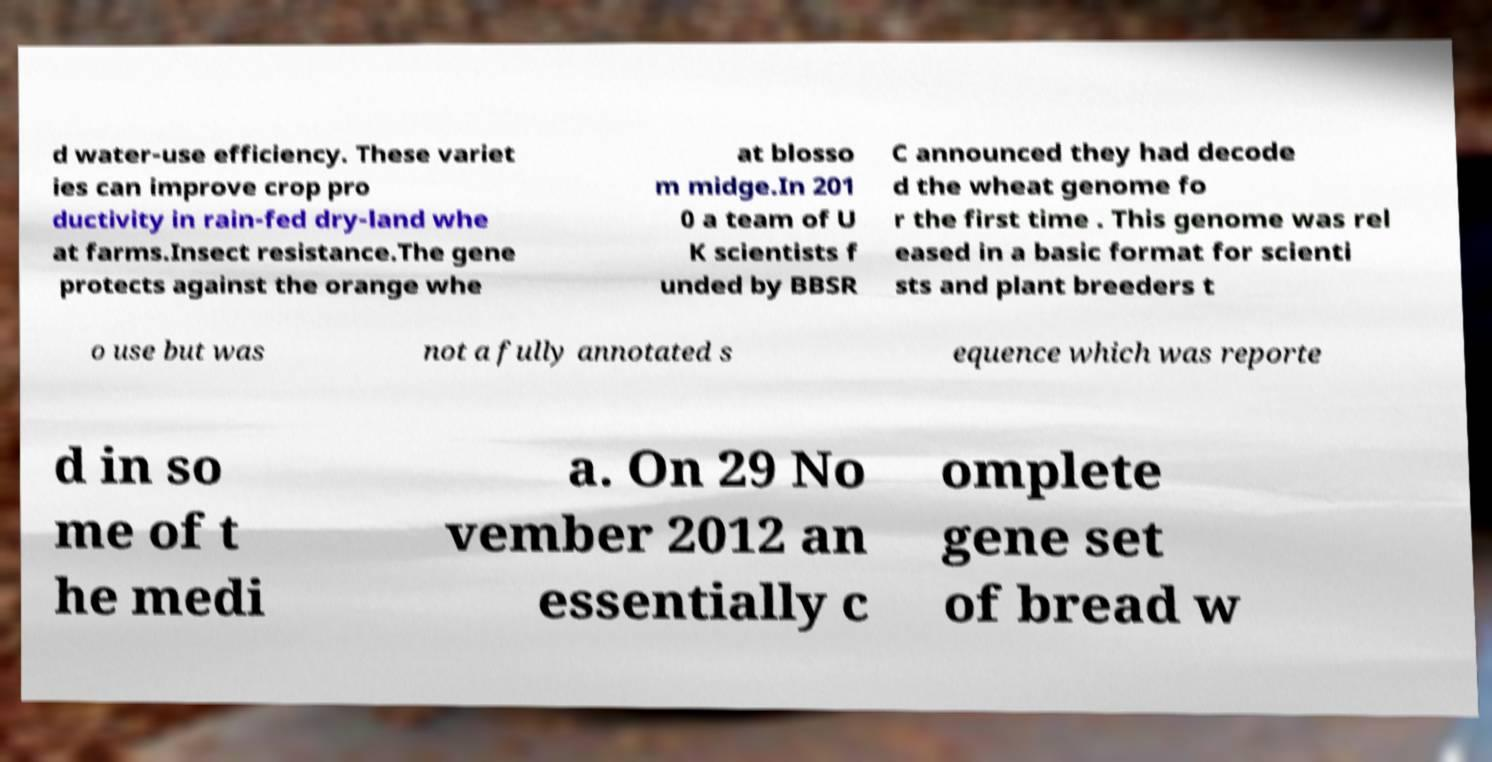Please read and relay the text visible in this image. What does it say? d water-use efficiency. These variet ies can improve crop pro ductivity in rain-fed dry-land whe at farms.Insect resistance.The gene protects against the orange whe at blosso m midge.In 201 0 a team of U K scientists f unded by BBSR C announced they had decode d the wheat genome fo r the first time . This genome was rel eased in a basic format for scienti sts and plant breeders t o use but was not a fully annotated s equence which was reporte d in so me of t he medi a. On 29 No vember 2012 an essentially c omplete gene set of bread w 